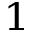<formula> <loc_0><loc_0><loc_500><loc_500>^ { 1 }</formula> 